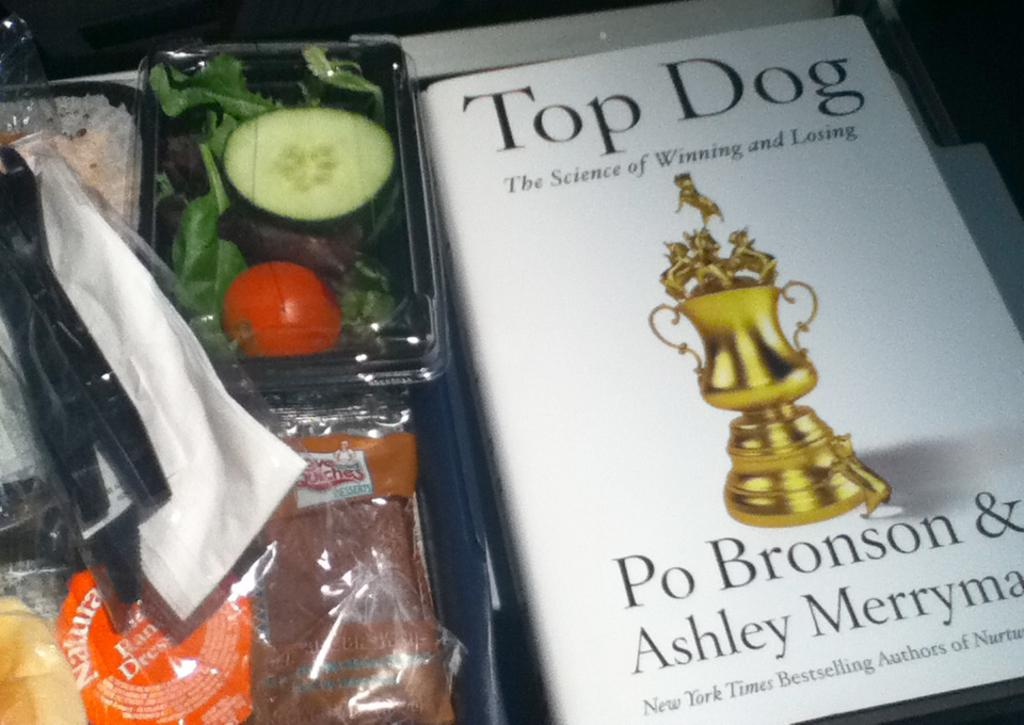<image>
Relay a brief, clear account of the picture shown. A copy of the book Top Dog by Po Bronson and Ashly Merryman. 